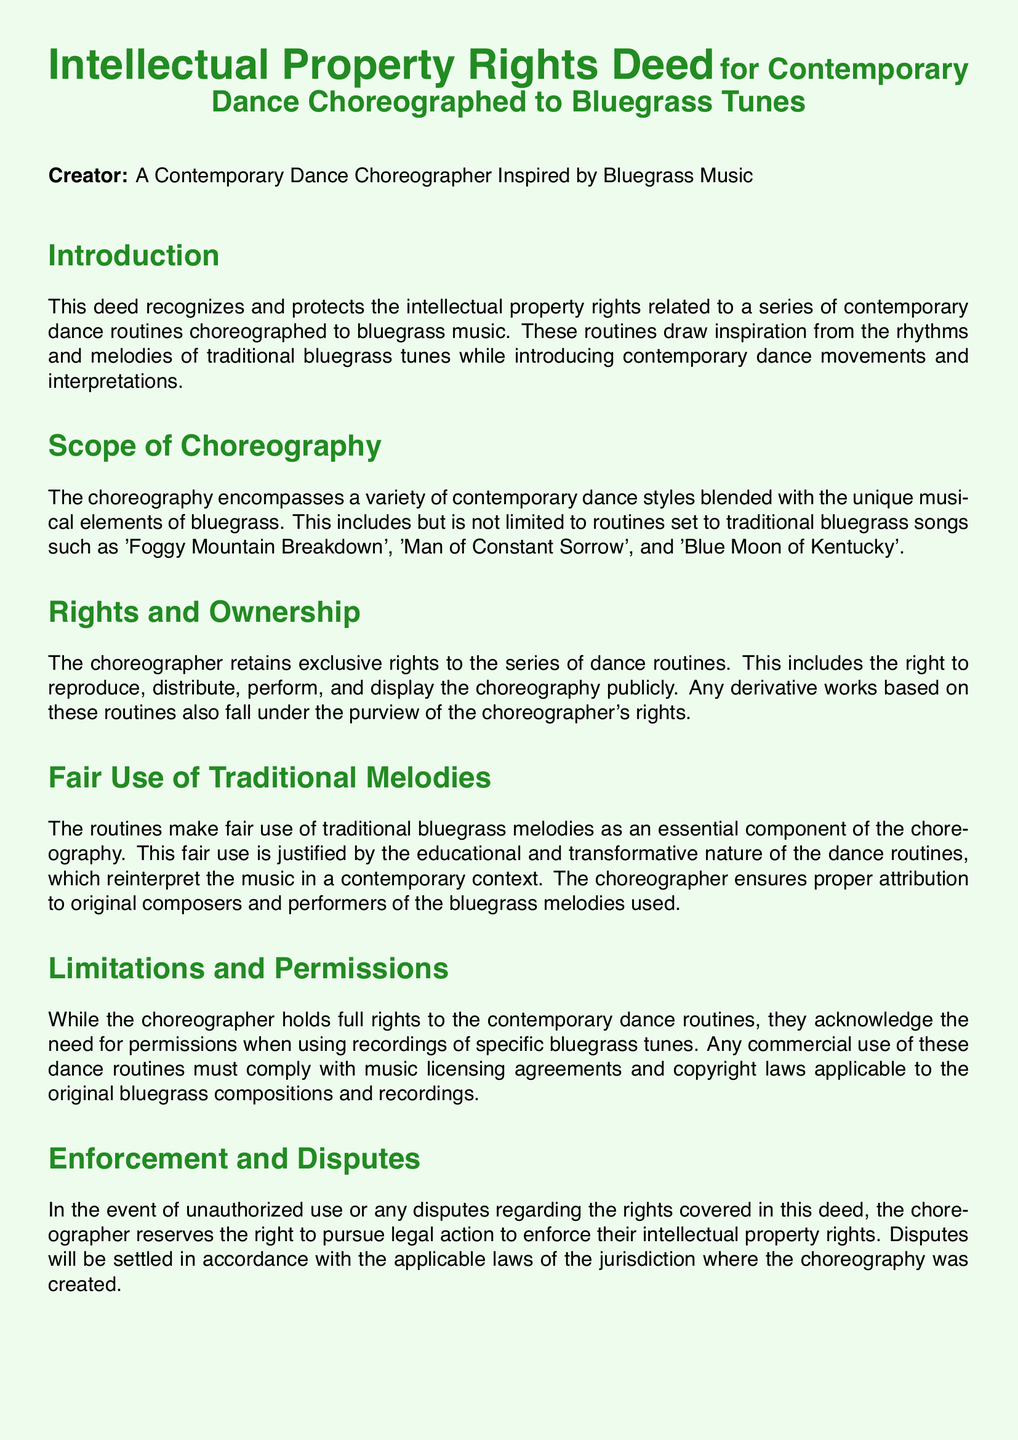What is the title of the document? The title of the document is the main heading that indicates its purpose, referring specifically to intellectual property related to dance.
Answer: Intellectual Property Rights Deed Who is the creator of the choreographed routines? The creator is the individual responsible for the choreography, specifically mentioned in the document.
Answer: A Contemporary Dance Choreographer Inspired by Bluegrass Music What traditional bluegrass song is specifically mentioned first in the scope of choreography? The document lists specific songs in the choreography scope, particularly the first one mentioned.
Answer: Foggy Mountain Breakdown What type of rights does the choreographer retain? The document outlines the specific rights associated with the choreography that the choreographer maintains.
Answer: Exclusive rights What must be complied with for any commercial use of the dance routines? The document states a requirement that must be met when engaging in commercial activities involving the routines.
Answer: Music licensing agreements What is the purpose of the fair use of traditional melodies in the document? The document explains the justification behind utilizing traditional melodies, emphasizing a particular aspect of the choreography's nature.
Answer: Educational and transformative How will disputes regarding rights be settled? The document provides a solution approach to issues arising from unauthorized use or conflicts about intellectual property rights.
Answer: Applicable laws of the jurisdiction What kind of acknowledgment is expressed in the document? The document includes a segment that appreciates contributions from a certain group related to bluegrass and its influence.
Answer: Cultural contributions of bluegrass musicians 